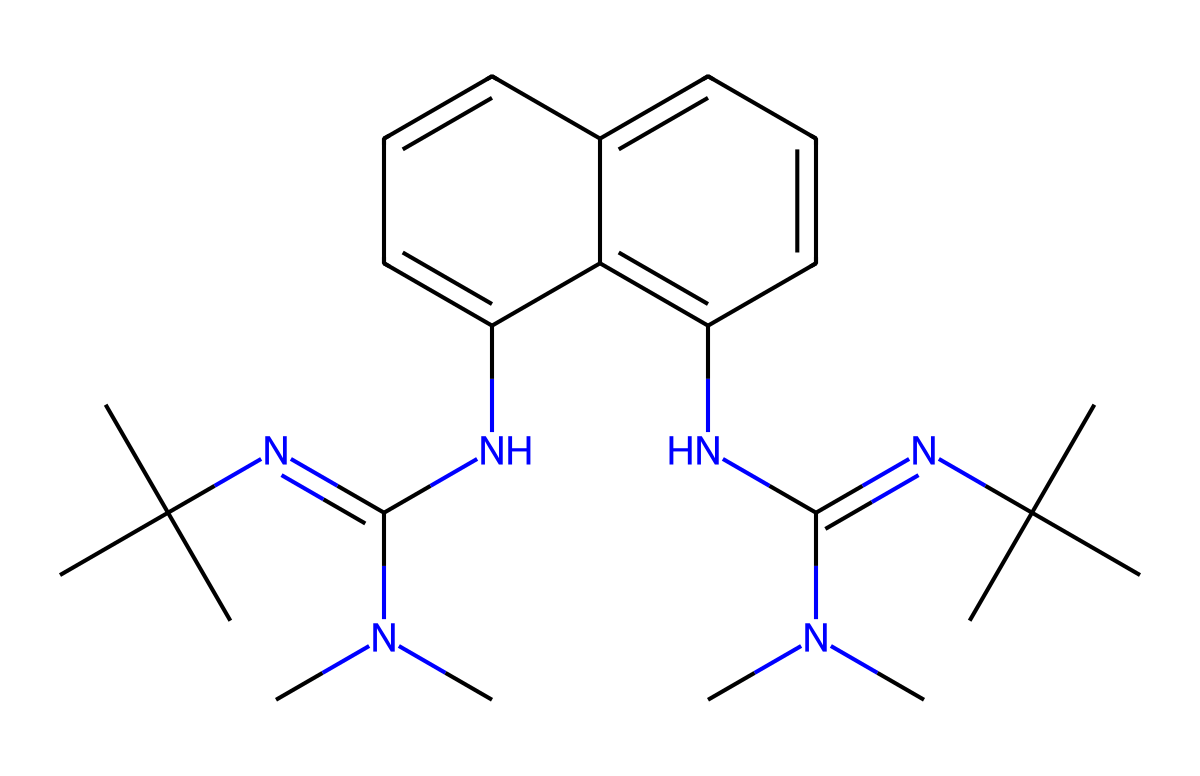What is the molecular formula of the chemical represented? To find the molecular formula, we count the elements in the SMILES representation. By analyzing the SMILES, we identify that there are 20 carbon (C) atoms, 36 hydrogen (H) atoms, and 4 nitrogen (N) atoms. Thus, the formula is C20H36N4.
Answer: C20H36N4 How many nitrogen atoms are present in this superbase? The SMILES indicates four distinct nitrogen atoms that occur in various functional groups throughout the structure.
Answer: 4 What type of bonding is observed between the carbon and nitrogen atoms? The connection between carbon (C) and nitrogen (N) atoms involves covalent bonding. In the given structure, nitrogen's ability to form multiple bonds occurs as seen in the connections to carbon atoms.
Answer: covalent What does the presence of tertiary amines in the structure indicate? Tertiary amines usually suggest a highly basic nature, as they contain three organic substituents attached to a nitrogen atom, making them potential superbases.
Answer: high basicity What makes 1,8-bis(tetramethylguanidino)naphthalene particularly useful in cosmetic formulations? The unique structural feature of this molecule, specifically its superbase nature due to multiple nitrogen atoms and bulky groups, enhances its ability to influence pH, enabling better formulation stability and skin compatibility.
Answer: stability and compatibility How many rings are in the structure of this molecule? By examining the structure via the SMILES, we identify that there are two fused aromatic rings present connected to the guanidino groups, characteristic of naphthalene.
Answer: 2 